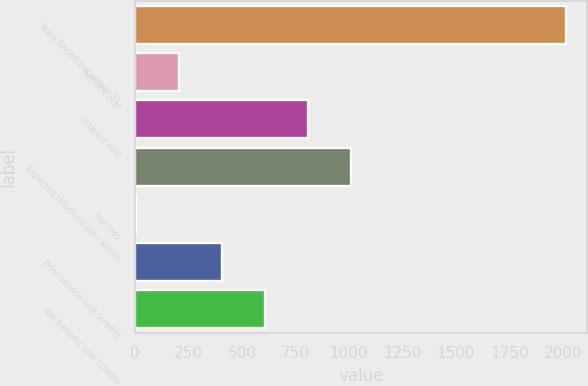Convert chart. <chart><loc_0><loc_0><loc_500><loc_500><bar_chart><fcel>Years Ended December 31<fcel>Service cost<fcel>Interest cost<fcel>Expected return on plan assets<fcel>Net loss<fcel>Prior service cost (credit)<fcel>Net periodic cost (credit)<nl><fcel>2014<fcel>203.2<fcel>806.8<fcel>1008<fcel>2<fcel>404.4<fcel>605.6<nl></chart> 